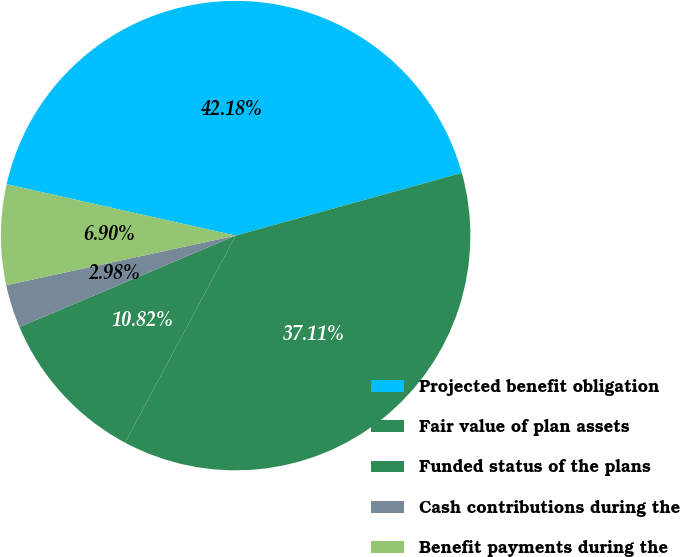Convert chart. <chart><loc_0><loc_0><loc_500><loc_500><pie_chart><fcel>Projected benefit obligation<fcel>Fair value of plan assets<fcel>Funded status of the plans<fcel>Cash contributions during the<fcel>Benefit payments during the<nl><fcel>42.18%<fcel>37.11%<fcel>10.82%<fcel>2.98%<fcel>6.9%<nl></chart> 